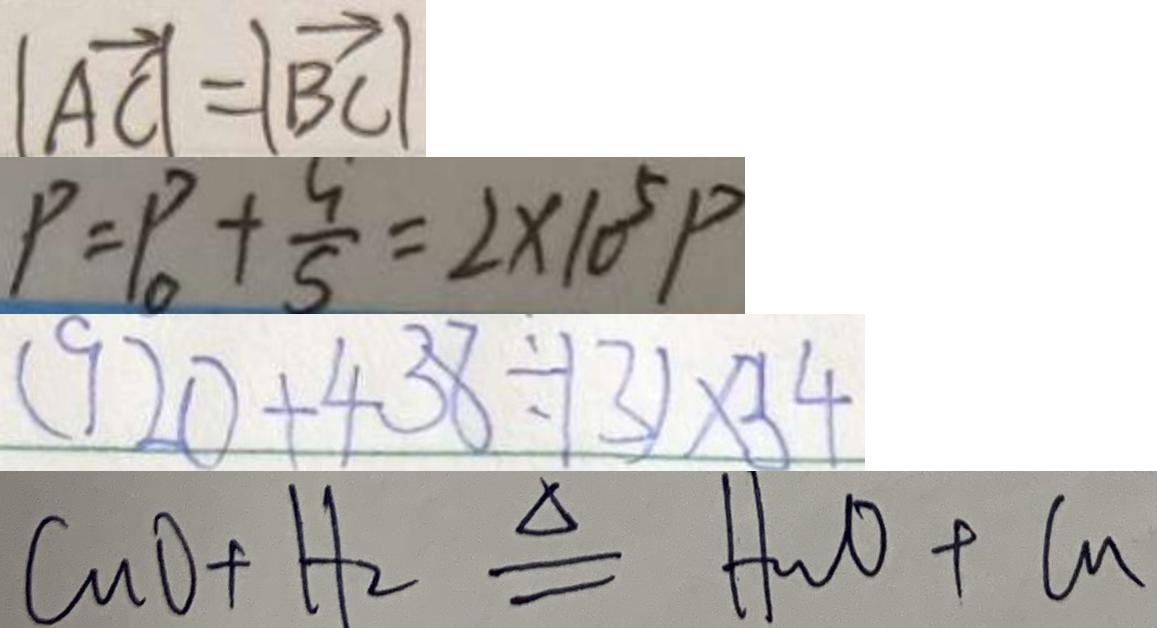<formula> <loc_0><loc_0><loc_500><loc_500>\vert \overrightarrow { A C } \vert = \vert \overrightarrow { B C } \vert 
 P = P _ { 0 } + \frac { G } { S } = 2 \times 1 0 ^ { 5 } P 
 ( 9 2 0 + 4 3 8 \div 1 3 ) \times 3 4 
 C u O + H _ { 2 } \xlongequal { \Delta } H _ { 2 } O + C u</formula> 